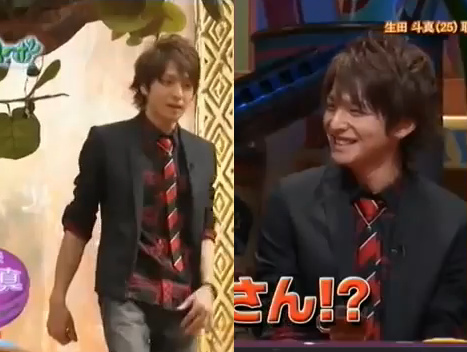Who wears the coat? The man is wearing the coat. 